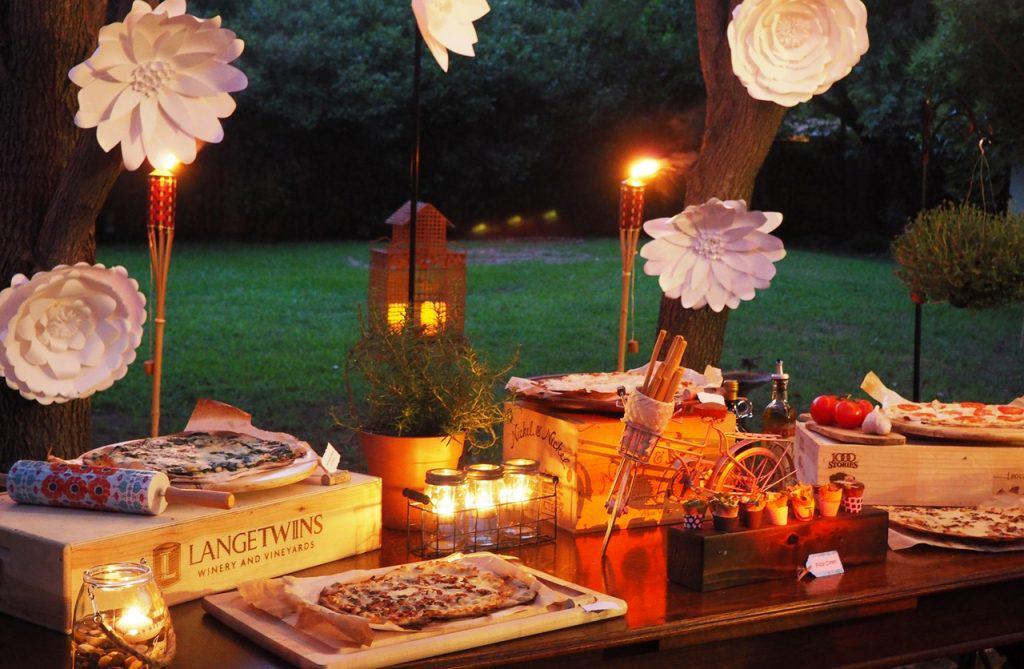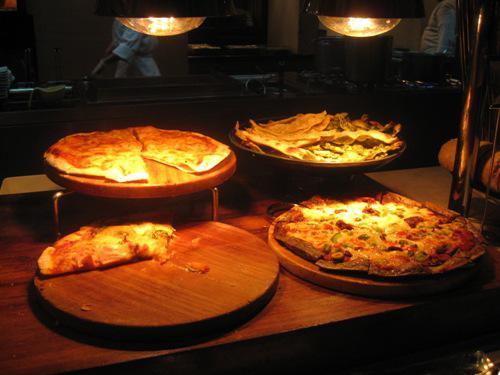The first image is the image on the left, the second image is the image on the right. Evaluate the accuracy of this statement regarding the images: "In the image on the right, some pizzas are raised on stands.". Is it true? Answer yes or no. Yes. The first image is the image on the left, the second image is the image on the right. Given the left and right images, does the statement "A sign on the chalkboard is announcing the food on the table in one of the images." hold true? Answer yes or no. No. 